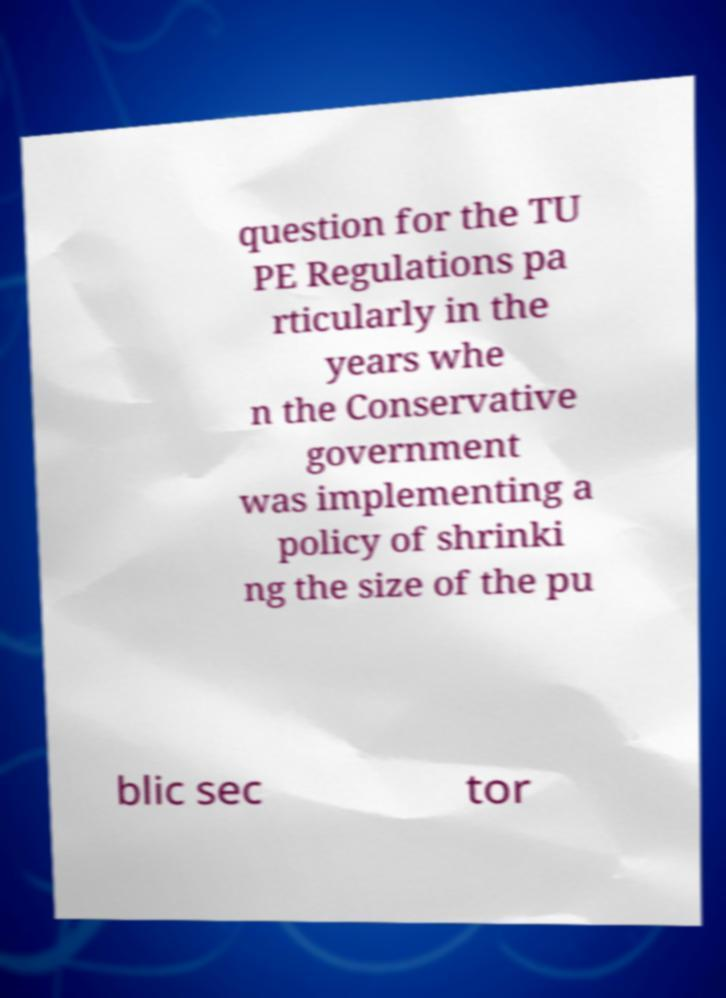Can you read and provide the text displayed in the image?This photo seems to have some interesting text. Can you extract and type it out for me? question for the TU PE Regulations pa rticularly in the years whe n the Conservative government was implementing a policy of shrinki ng the size of the pu blic sec tor 